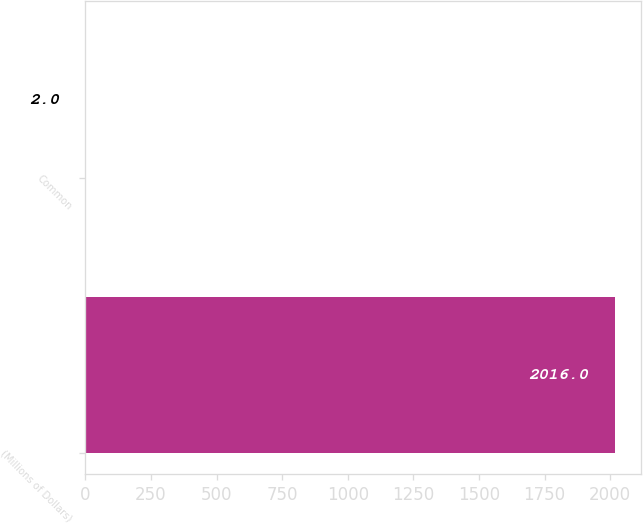Convert chart. <chart><loc_0><loc_0><loc_500><loc_500><bar_chart><fcel>(Millions of Dollars)<fcel>Common<nl><fcel>2016<fcel>2<nl></chart> 